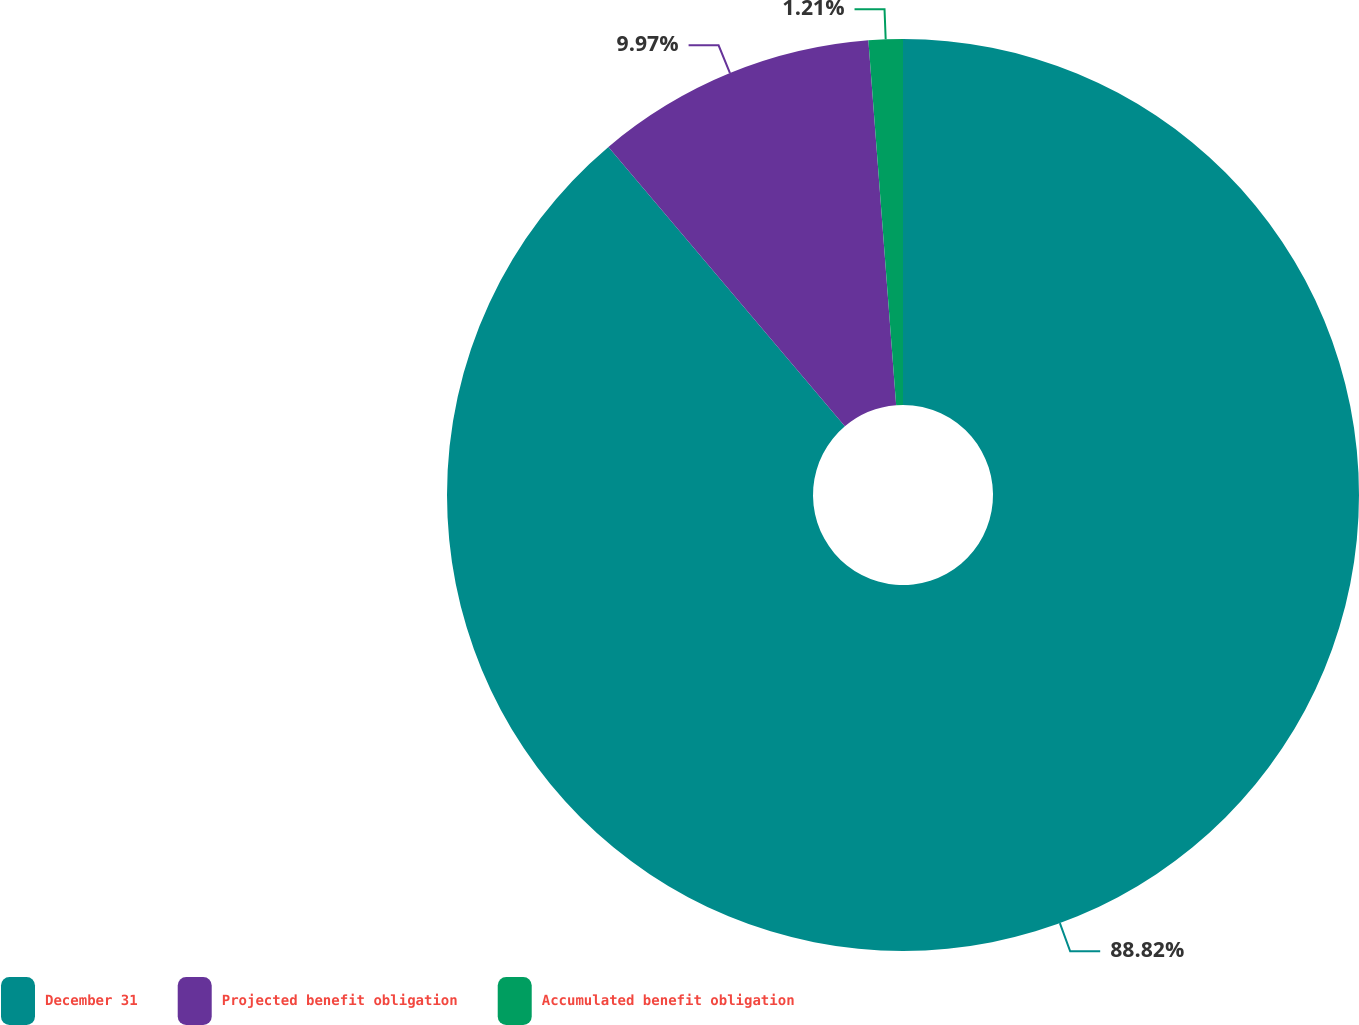Convert chart. <chart><loc_0><loc_0><loc_500><loc_500><pie_chart><fcel>December 31<fcel>Projected benefit obligation<fcel>Accumulated benefit obligation<nl><fcel>88.83%<fcel>9.97%<fcel>1.21%<nl></chart> 